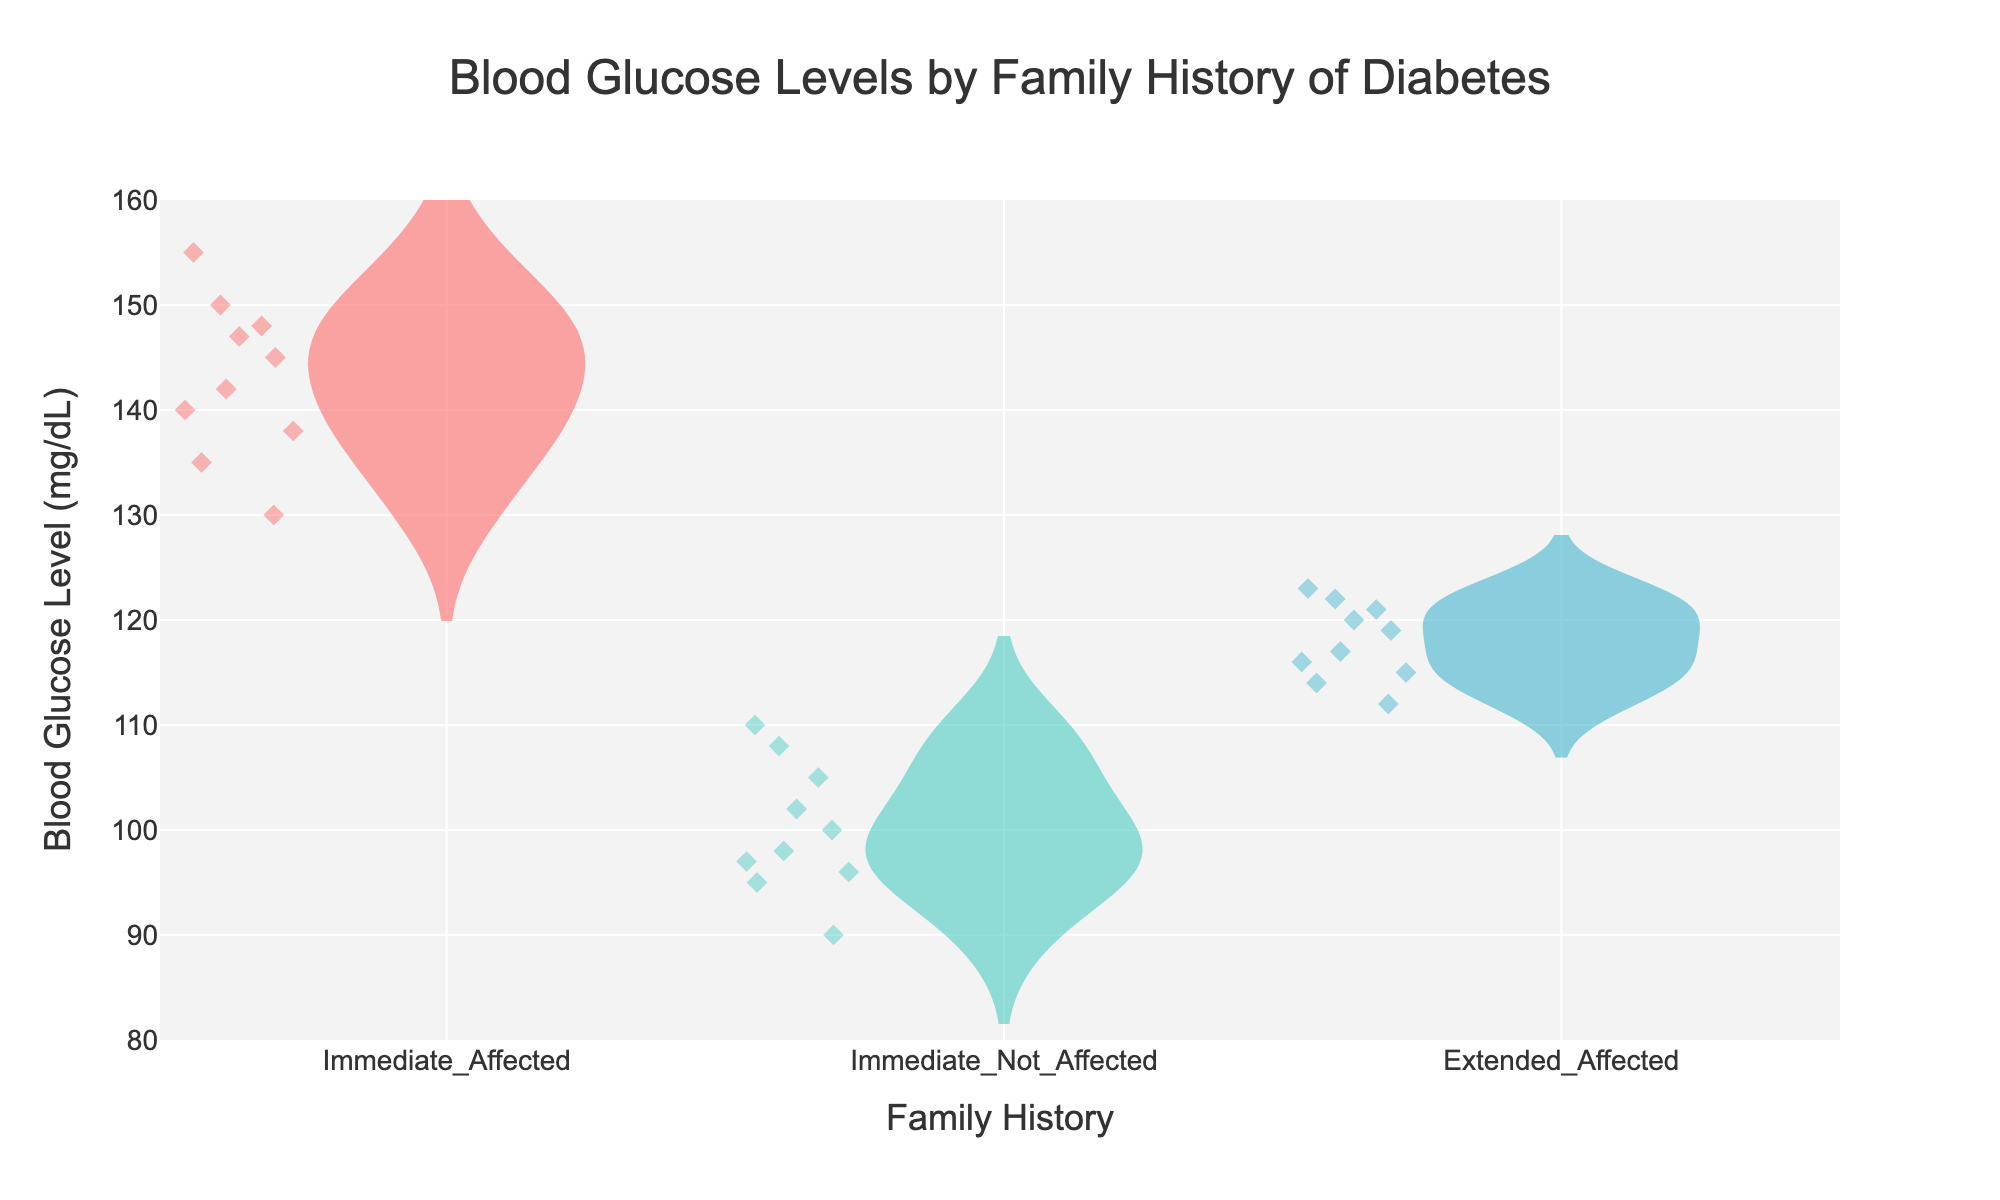what is the title of the figure? The title of the chart is located at the top center of the visual and reads "Blood Glucose Levels by Family History of Diabetes".
Answer: Blood Glucose Levels by Family History of Diabetes How many distinct family history groups are there? The distinct categories of family history groups are marked on the x-axis. There are three labels: Immediate_Affected, Immediate_Not_Affected, and Extended_Affected.
Answer: 3 Which family history group has the highest blood glucose level? By examining the highest points on the y-axis for each group, "Immediate_Affected" has the maximum value, reaching up to about 155 mg/dL.
Answer: Immediate_Affected What is the range of blood glucose levels for the Immediate_Not_Affected group? For the Immediate_Not_Affected group, observe the spread of the data points along the y-axis, which ranges between approximately 90 and 110 mg/dL.
Answer: 90 to 110 mg/dL Do children in the Extended_Affected group generally have higher blood glucose levels than those in the Immediate_Not_Affected group? Compare the positions of the violin plots and jittered points: the Extended_Affected group spans roughly from 112 to 123 mg/dL, and the Immediate_Not_Affected group spans from 90 to 110 mg/dL, showing a generally higher level for the Extended_Affected group.
Answer: Yes Which family history group has the narrowest range of blood glucose levels? Inspect the spread of data points for each group. The Immediate_Not_Affected group shows the narrowest range, as their points vary only between 90 and 110 mg/dL.
Answer: Immediate_Not_Affected Approximately what is the mean blood glucose level for the Immediate_Affected group? The mean is shown by a horizontal line within the violin plot. For the Immediate_Affected group, the mean blood glucose level is roughly around 142 mg/dL.
Answer: 142 mg/dL Which family history group has the most variability in blood glucose levels? Variability is indicated by the spread and the shape of the violin plot. The Immediate_Affected group shows the widest spread and most varied distribution, ranging from 130 to 155 mg/dL.
Answer: Immediate_Affected Is there overlap in blood glucose levels between Immediate_Affected and Extended_Affected groups? By observing the distribution overlap, the Extended_Affected group spans from 112 to 123 mg/dL and the Immediate_Affected group spans from 130 to 155 mg/dL with no overlap between their ranges.
Answer: No Of all the data points, which family history group has the lowest individual blood glucose measurement? The lowest single data point can be identified on the y-axis. It belongs to the Immediate_Not_Affected group, which has measurements starting from 90 mg/dL.
Answer: Immediate_Not_Affected 